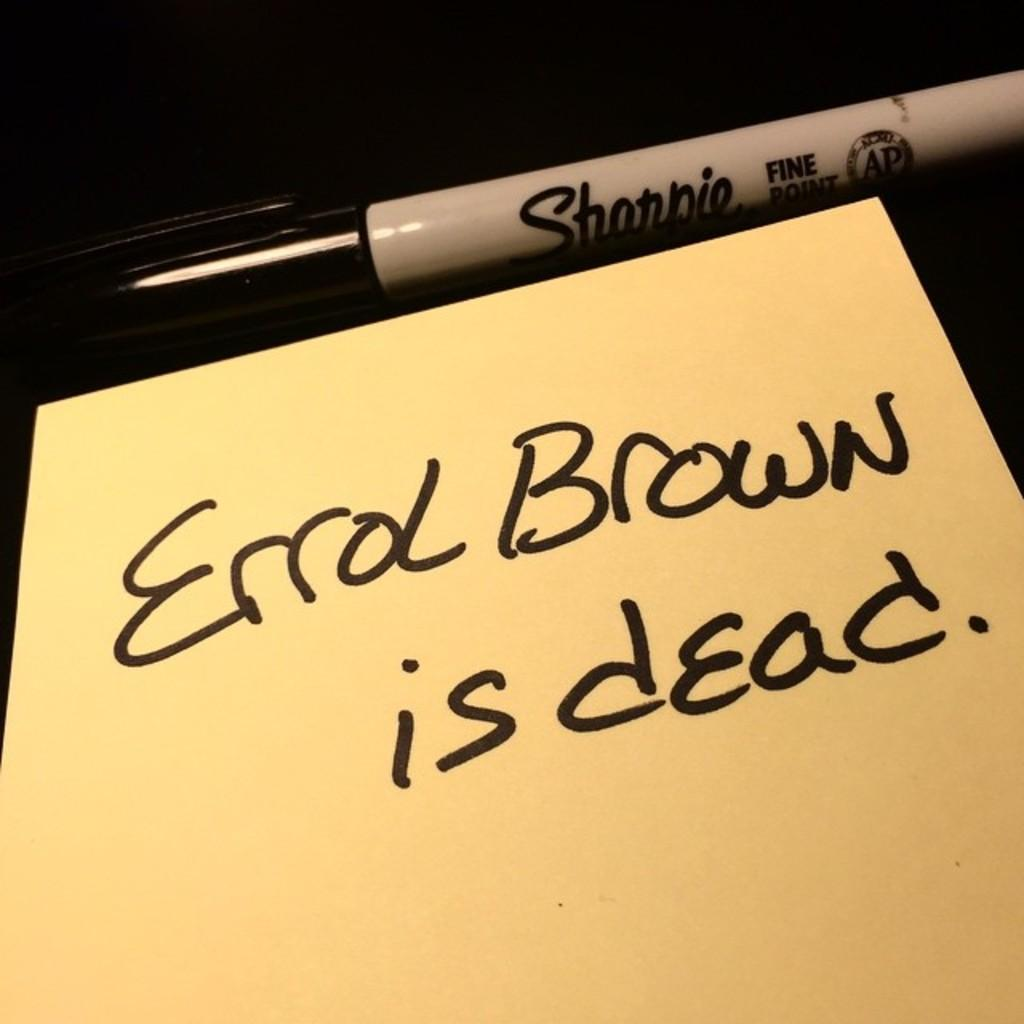What is written on the paper in the image? There is text on a paper in the image. What object is present in the image that could be used to write or draw? There is a marker in the image. What is written on the marker itself? There is text on the marker. What color is the background of the image? The background of the image is black. How many boats are visible in the image? There are no boats present in the image. What type of number is written on the paper in the image? There is no mention of a number being written on the paper in the image. 